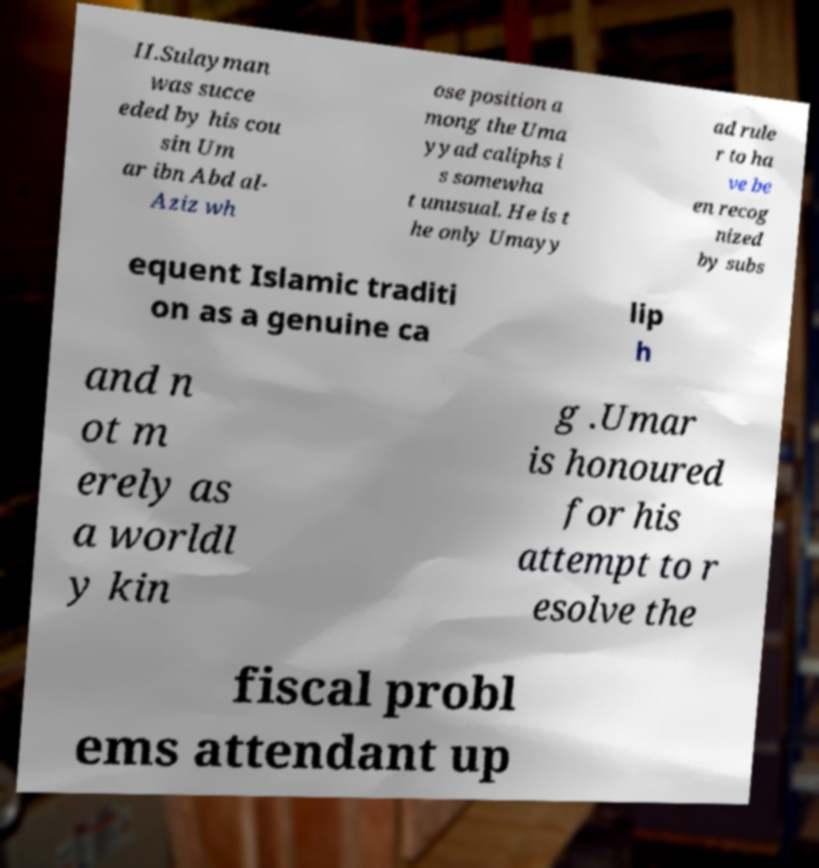I need the written content from this picture converted into text. Can you do that? II.Sulayman was succe eded by his cou sin Um ar ibn Abd al- Aziz wh ose position a mong the Uma yyad caliphs i s somewha t unusual. He is t he only Umayy ad rule r to ha ve be en recog nized by subs equent Islamic traditi on as a genuine ca lip h and n ot m erely as a worldl y kin g .Umar is honoured for his attempt to r esolve the fiscal probl ems attendant up 